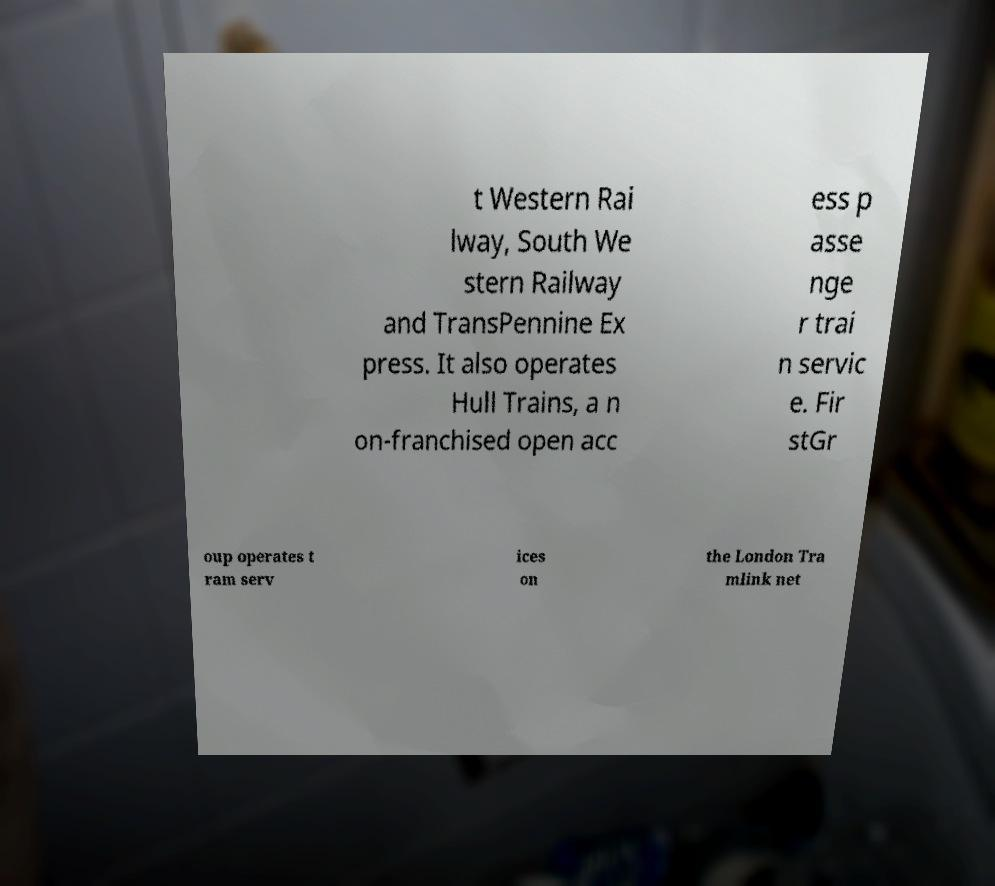There's text embedded in this image that I need extracted. Can you transcribe it verbatim? t Western Rai lway, South We stern Railway and TransPennine Ex press. It also operates Hull Trains, a n on-franchised open acc ess p asse nge r trai n servic e. Fir stGr oup operates t ram serv ices on the London Tra mlink net 